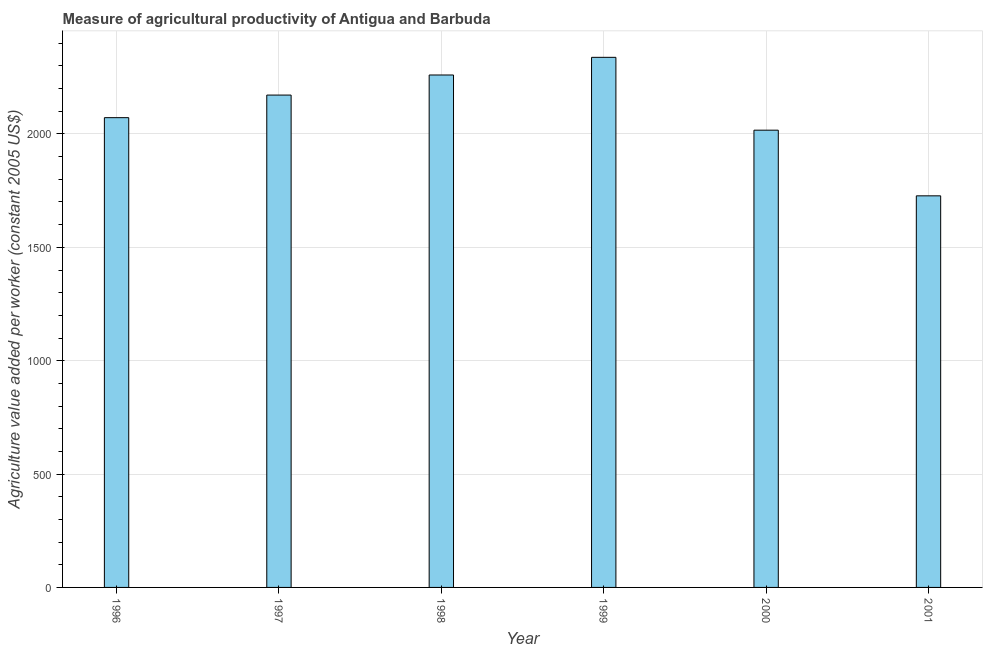Does the graph contain grids?
Your response must be concise. Yes. What is the title of the graph?
Offer a very short reply. Measure of agricultural productivity of Antigua and Barbuda. What is the label or title of the X-axis?
Your response must be concise. Year. What is the label or title of the Y-axis?
Your answer should be compact. Agriculture value added per worker (constant 2005 US$). What is the agriculture value added per worker in 1999?
Provide a short and direct response. 2338.04. Across all years, what is the maximum agriculture value added per worker?
Give a very brief answer. 2338.04. Across all years, what is the minimum agriculture value added per worker?
Your answer should be very brief. 1727.16. What is the sum of the agriculture value added per worker?
Your answer should be very brief. 1.26e+04. What is the difference between the agriculture value added per worker in 2000 and 2001?
Give a very brief answer. 289.61. What is the average agriculture value added per worker per year?
Your response must be concise. 2097.61. What is the median agriculture value added per worker?
Provide a succinct answer. 2121.78. Do a majority of the years between 2001 and 1996 (inclusive) have agriculture value added per worker greater than 1400 US$?
Provide a succinct answer. Yes. What is the ratio of the agriculture value added per worker in 1997 to that in 1998?
Offer a very short reply. 0.96. What is the difference between the highest and the second highest agriculture value added per worker?
Your answer should be very brief. 77.93. What is the difference between the highest and the lowest agriculture value added per worker?
Offer a very short reply. 610.89. Are all the bars in the graph horizontal?
Your answer should be very brief. No. What is the Agriculture value added per worker (constant 2005 US$) of 1996?
Provide a short and direct response. 2071.96. What is the Agriculture value added per worker (constant 2005 US$) of 1997?
Your response must be concise. 2171.6. What is the Agriculture value added per worker (constant 2005 US$) of 1998?
Keep it short and to the point. 2260.11. What is the Agriculture value added per worker (constant 2005 US$) of 1999?
Give a very brief answer. 2338.04. What is the Agriculture value added per worker (constant 2005 US$) in 2000?
Keep it short and to the point. 2016.77. What is the Agriculture value added per worker (constant 2005 US$) in 2001?
Your response must be concise. 1727.16. What is the difference between the Agriculture value added per worker (constant 2005 US$) in 1996 and 1997?
Make the answer very short. -99.64. What is the difference between the Agriculture value added per worker (constant 2005 US$) in 1996 and 1998?
Ensure brevity in your answer.  -188.16. What is the difference between the Agriculture value added per worker (constant 2005 US$) in 1996 and 1999?
Keep it short and to the point. -266.09. What is the difference between the Agriculture value added per worker (constant 2005 US$) in 1996 and 2000?
Make the answer very short. 55.19. What is the difference between the Agriculture value added per worker (constant 2005 US$) in 1996 and 2001?
Give a very brief answer. 344.8. What is the difference between the Agriculture value added per worker (constant 2005 US$) in 1997 and 1998?
Provide a succinct answer. -88.51. What is the difference between the Agriculture value added per worker (constant 2005 US$) in 1997 and 1999?
Offer a terse response. -166.45. What is the difference between the Agriculture value added per worker (constant 2005 US$) in 1997 and 2000?
Offer a terse response. 154.83. What is the difference between the Agriculture value added per worker (constant 2005 US$) in 1997 and 2001?
Ensure brevity in your answer.  444.44. What is the difference between the Agriculture value added per worker (constant 2005 US$) in 1998 and 1999?
Provide a succinct answer. -77.93. What is the difference between the Agriculture value added per worker (constant 2005 US$) in 1998 and 2000?
Ensure brevity in your answer.  243.35. What is the difference between the Agriculture value added per worker (constant 2005 US$) in 1998 and 2001?
Make the answer very short. 532.95. What is the difference between the Agriculture value added per worker (constant 2005 US$) in 1999 and 2000?
Make the answer very short. 321.28. What is the difference between the Agriculture value added per worker (constant 2005 US$) in 1999 and 2001?
Your answer should be compact. 610.89. What is the difference between the Agriculture value added per worker (constant 2005 US$) in 2000 and 2001?
Give a very brief answer. 289.61. What is the ratio of the Agriculture value added per worker (constant 2005 US$) in 1996 to that in 1997?
Give a very brief answer. 0.95. What is the ratio of the Agriculture value added per worker (constant 2005 US$) in 1996 to that in 1998?
Make the answer very short. 0.92. What is the ratio of the Agriculture value added per worker (constant 2005 US$) in 1996 to that in 1999?
Your answer should be very brief. 0.89. What is the ratio of the Agriculture value added per worker (constant 2005 US$) in 1997 to that in 1998?
Your answer should be compact. 0.96. What is the ratio of the Agriculture value added per worker (constant 2005 US$) in 1997 to that in 1999?
Offer a very short reply. 0.93. What is the ratio of the Agriculture value added per worker (constant 2005 US$) in 1997 to that in 2000?
Keep it short and to the point. 1.08. What is the ratio of the Agriculture value added per worker (constant 2005 US$) in 1997 to that in 2001?
Give a very brief answer. 1.26. What is the ratio of the Agriculture value added per worker (constant 2005 US$) in 1998 to that in 1999?
Provide a succinct answer. 0.97. What is the ratio of the Agriculture value added per worker (constant 2005 US$) in 1998 to that in 2000?
Your answer should be very brief. 1.12. What is the ratio of the Agriculture value added per worker (constant 2005 US$) in 1998 to that in 2001?
Your answer should be compact. 1.31. What is the ratio of the Agriculture value added per worker (constant 2005 US$) in 1999 to that in 2000?
Offer a terse response. 1.16. What is the ratio of the Agriculture value added per worker (constant 2005 US$) in 1999 to that in 2001?
Offer a very short reply. 1.35. What is the ratio of the Agriculture value added per worker (constant 2005 US$) in 2000 to that in 2001?
Ensure brevity in your answer.  1.17. 